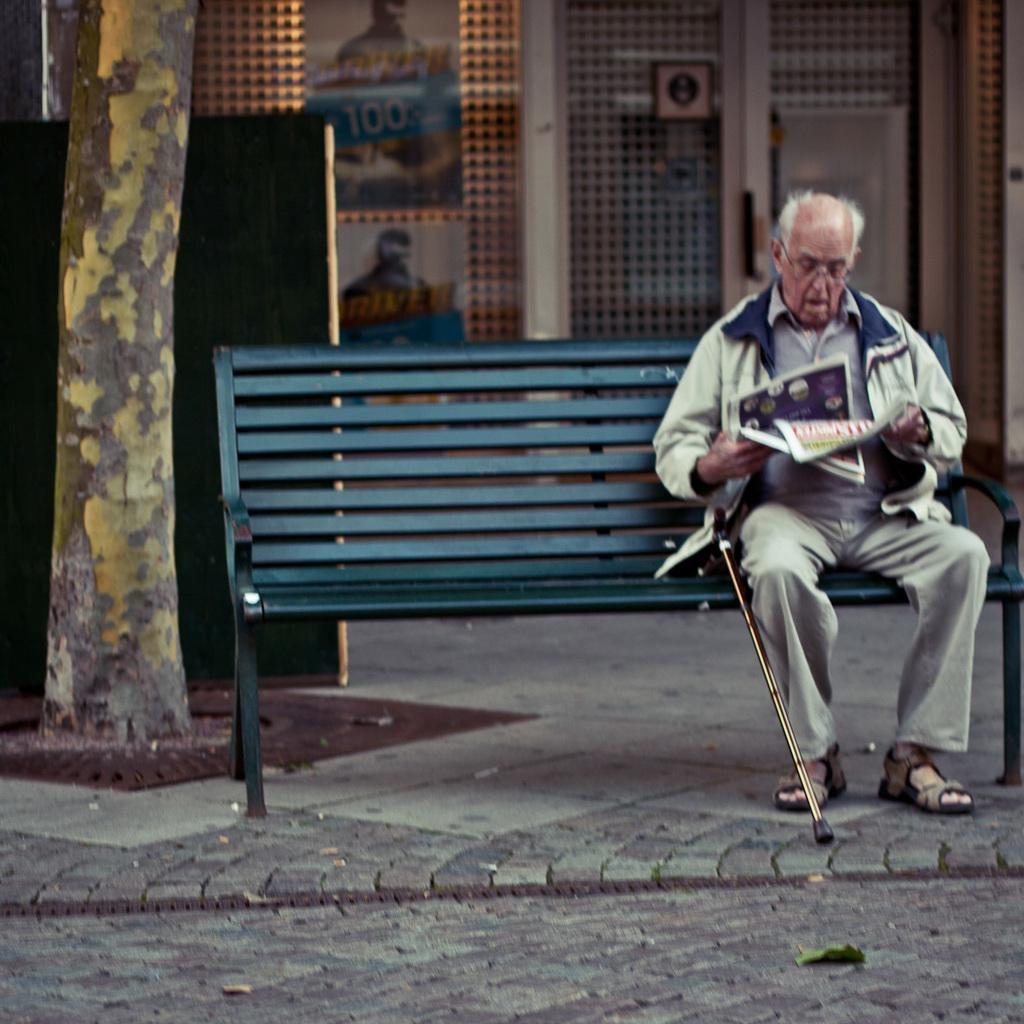What is present in the image? There is a man in the image. What is the man doing in the image? The man is sitting on a bench. What type of design can be seen on the trail in the image? There is no trail present in the image; it only features a man sitting on a bench. What type of spoon is being used by the man in the image? There is no spoon present in the image; the man is simply sitting on a bench. 